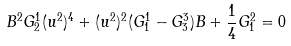Convert formula to latex. <formula><loc_0><loc_0><loc_500><loc_500>B ^ { 2 } G ^ { 1 } _ { 2 } ( u ^ { 2 } ) ^ { 4 } + ( u ^ { 2 } ) ^ { 2 } ( G ^ { 1 } _ { 1 } - G ^ { 3 } _ { 3 } ) B + \frac { 1 } { 4 } G ^ { 2 } _ { 1 } = 0</formula> 